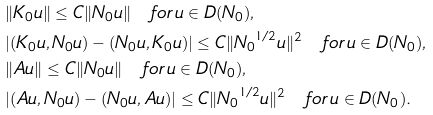Convert formula to latex. <formula><loc_0><loc_0><loc_500><loc_500>& \| K _ { 0 } u \| \leq C \| N _ { 0 } u \| \quad f o r \, u \in D ( N _ { 0 } ) , \\ & | ( K _ { 0 } u , N _ { 0 } u ) - ( N _ { 0 } u , K _ { 0 } u ) | \leq C \| { N _ { 0 } } ^ { 1 / 2 } u \| ^ { 2 } \quad f o r \, u \in D ( N _ { 0 } ) , \\ & \| A u \| \leq C \| N _ { 0 } u \| \quad f o r \, u \in D ( N _ { 0 } ) , \\ & | ( A u , N _ { 0 } u ) - ( N _ { 0 } u , A u ) | \leq C \| { N _ { 0 } } ^ { 1 / 2 } u \| ^ { 2 } \quad f o r \, u \in D ( N _ { 0 } ) .</formula> 